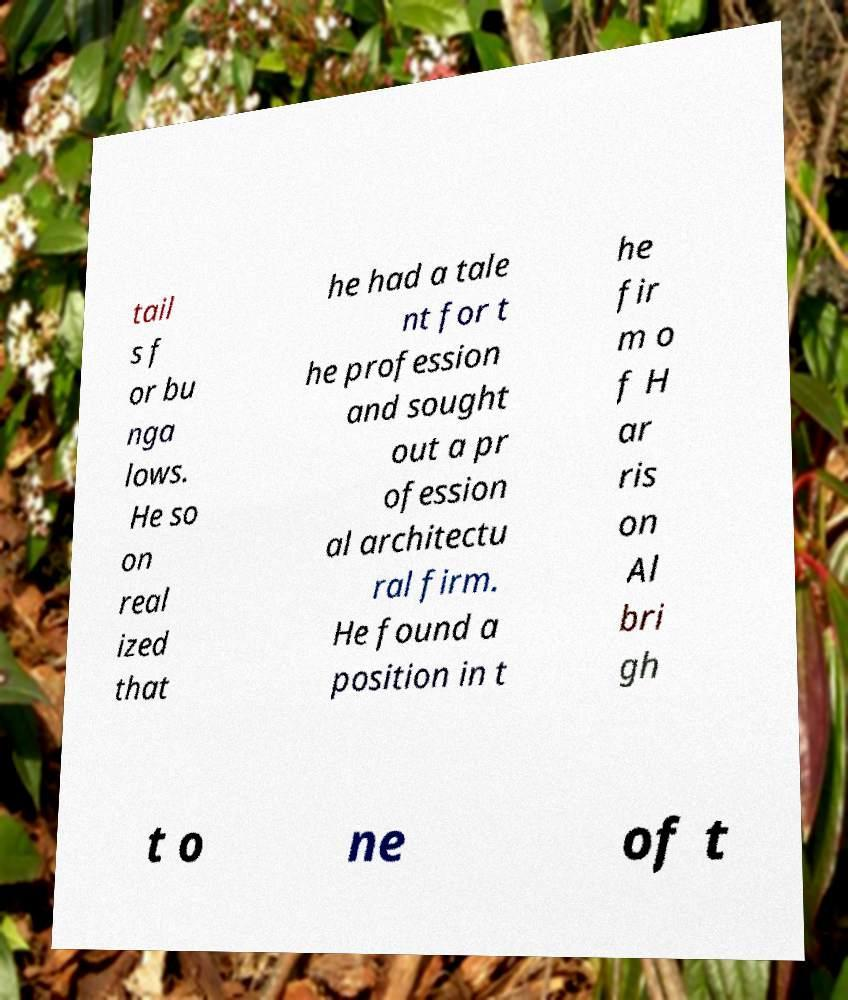For documentation purposes, I need the text within this image transcribed. Could you provide that? tail s f or bu nga lows. He so on real ized that he had a tale nt for t he profession and sought out a pr ofession al architectu ral firm. He found a position in t he fir m o f H ar ris on Al bri gh t o ne of t 